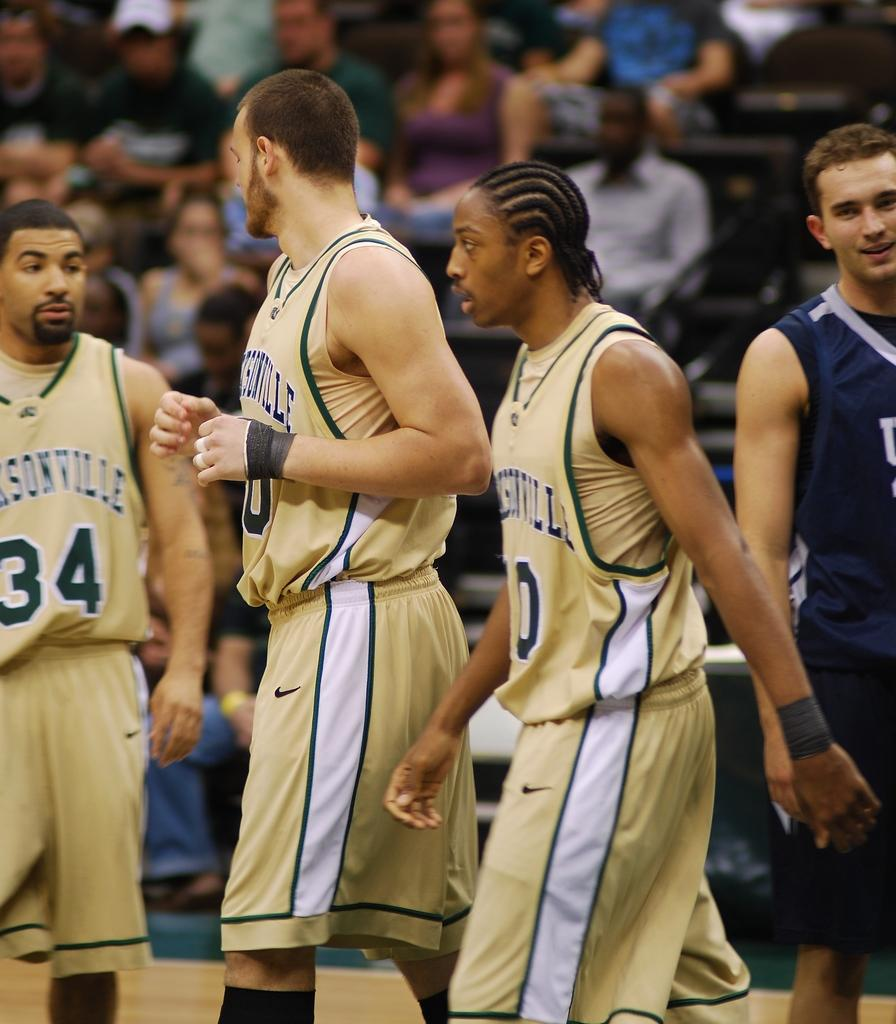<image>
Render a clear and concise summary of the photo. Three basketball players for Jacksonville have on uniforms made by Nike as they walk on the basketball court. 